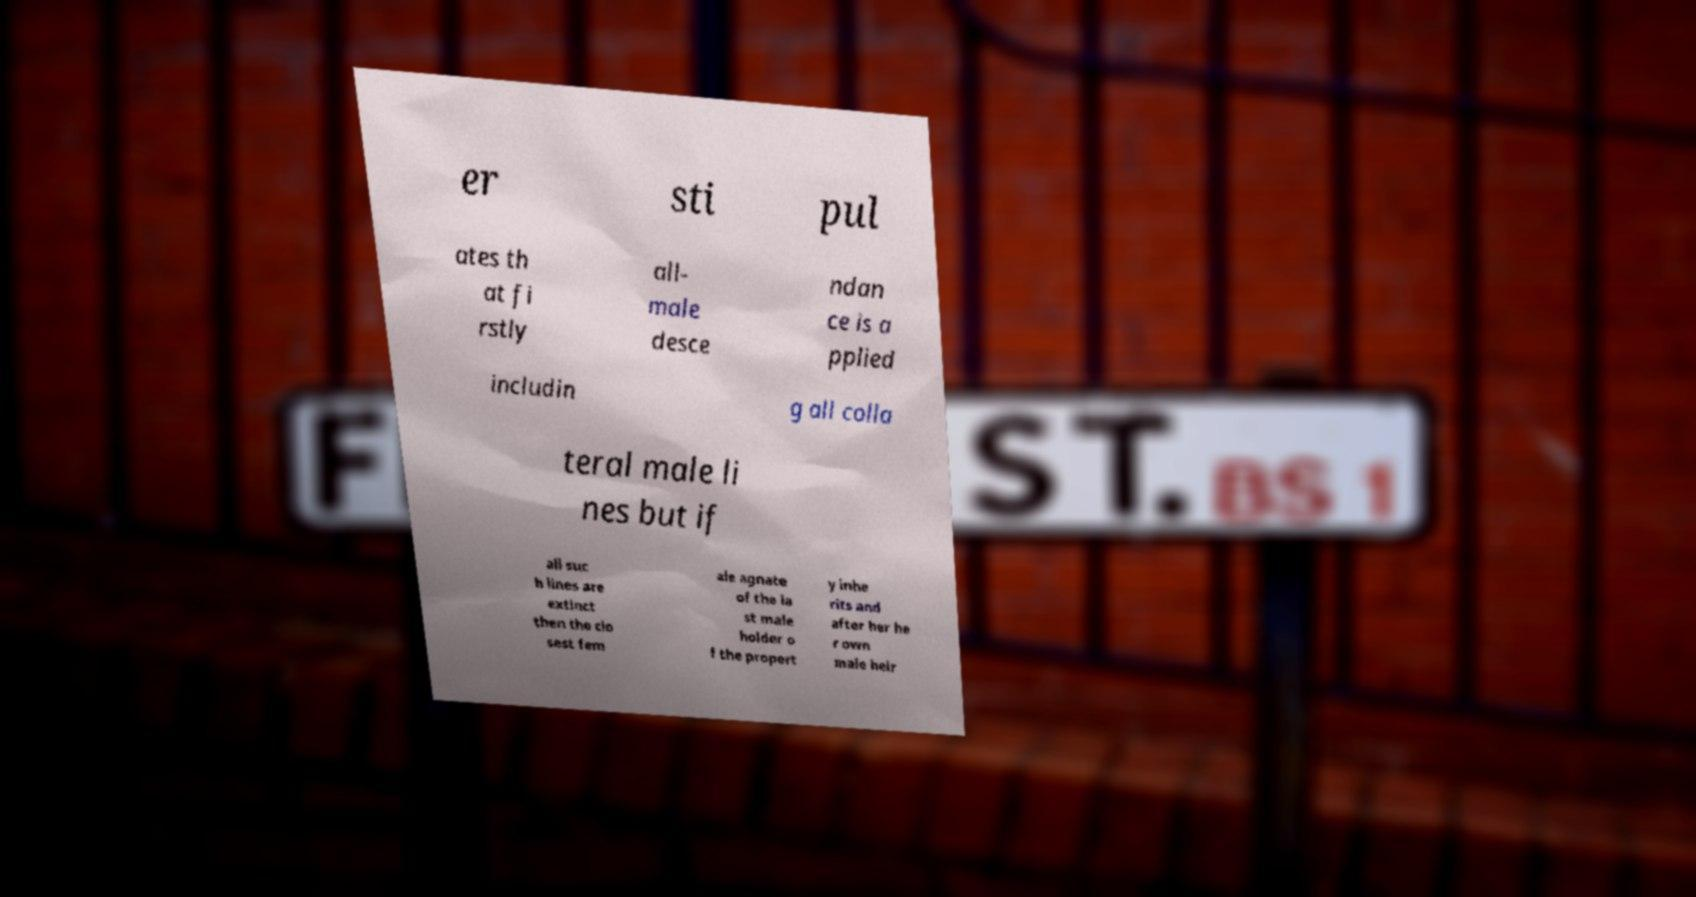Could you assist in decoding the text presented in this image and type it out clearly? er sti pul ates th at fi rstly all- male desce ndan ce is a pplied includin g all colla teral male li nes but if all suc h lines are extinct then the clo sest fem ale agnate of the la st male holder o f the propert y inhe rits and after her he r own male heir 